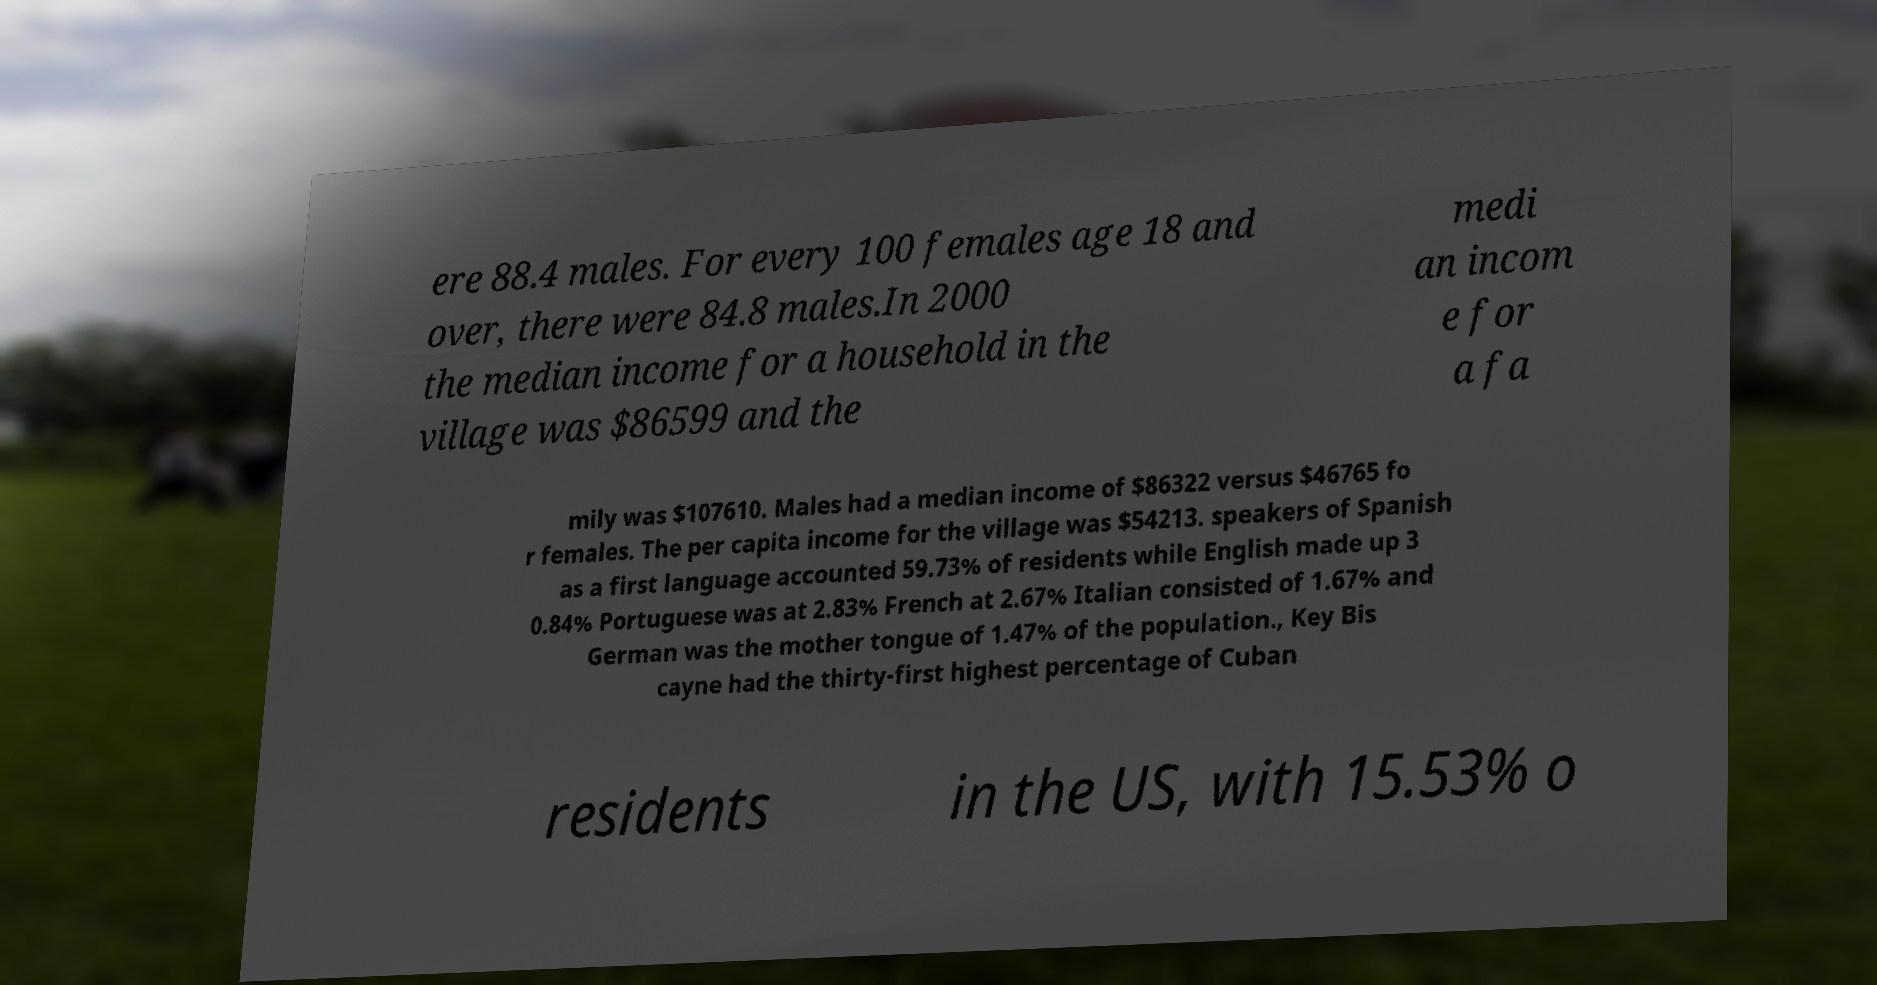I need the written content from this picture converted into text. Can you do that? ere 88.4 males. For every 100 females age 18 and over, there were 84.8 males.In 2000 the median income for a household in the village was $86599 and the medi an incom e for a fa mily was $107610. Males had a median income of $86322 versus $46765 fo r females. The per capita income for the village was $54213. speakers of Spanish as a first language accounted 59.73% of residents while English made up 3 0.84% Portuguese was at 2.83% French at 2.67% Italian consisted of 1.67% and German was the mother tongue of 1.47% of the population., Key Bis cayne had the thirty-first highest percentage of Cuban residents in the US, with 15.53% o 